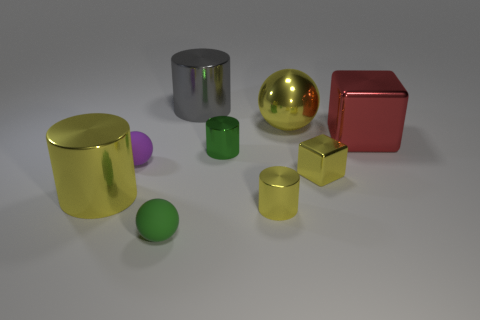There is another metal thing that is the same shape as the tiny purple object; what color is it?
Ensure brevity in your answer.  Yellow. Is there anything else that has the same shape as the large gray metal object?
Give a very brief answer. Yes. What number of blocks are either tiny green rubber things or gray metallic things?
Provide a succinct answer. 0. What is the shape of the green metal object?
Keep it short and to the point. Cylinder. There is a large gray metal object; are there any small yellow blocks on the left side of it?
Offer a terse response. No. Is the big yellow cylinder made of the same material as the big yellow object that is behind the large red cube?
Give a very brief answer. Yes. Is the shape of the yellow metal thing that is behind the large red metallic thing the same as  the big red object?
Make the answer very short. No. How many small cylinders have the same material as the yellow sphere?
Provide a short and direct response. 2. How many things are tiny green matte things in front of the gray metal cylinder or small cubes?
Your answer should be compact. 2. What is the size of the gray metallic thing?
Give a very brief answer. Large. 